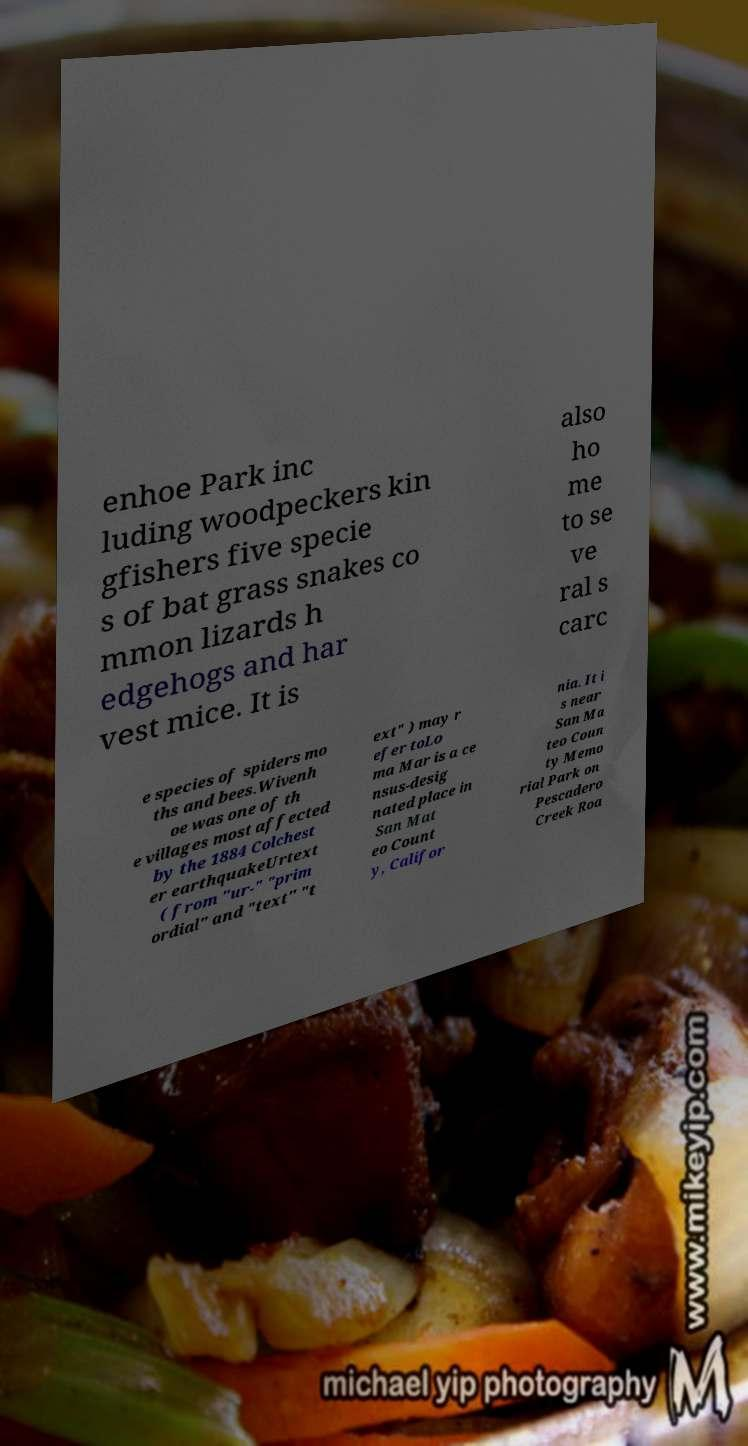Can you accurately transcribe the text from the provided image for me? enhoe Park inc luding woodpeckers kin gfishers five specie s of bat grass snakes co mmon lizards h edgehogs and har vest mice. It is also ho me to se ve ral s carc e species of spiders mo ths and bees.Wivenh oe was one of th e villages most affected by the 1884 Colchest er earthquakeUrtext ( from "ur-" "prim ordial" and "text" "t ext" ) may r efer toLo ma Mar is a ce nsus-desig nated place in San Mat eo Count y, Califor nia. It i s near San Ma teo Coun ty Memo rial Park on Pescadero Creek Roa 